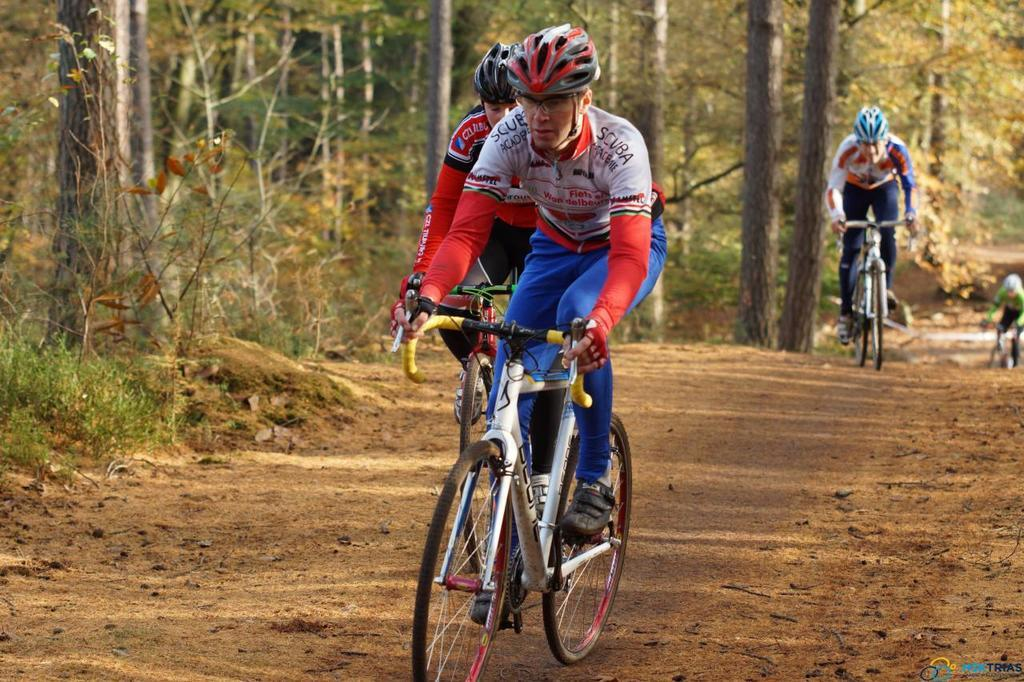Who or what is present in the image? There are people in the image. What are the people doing in the image? The people are cycling on the road. What can be seen in the background of the image? There are trees in the background of the image. What type of toy can be seen in the hands of the cyclists in the image? There are no toys present in the image; the people are cycling on the road. 